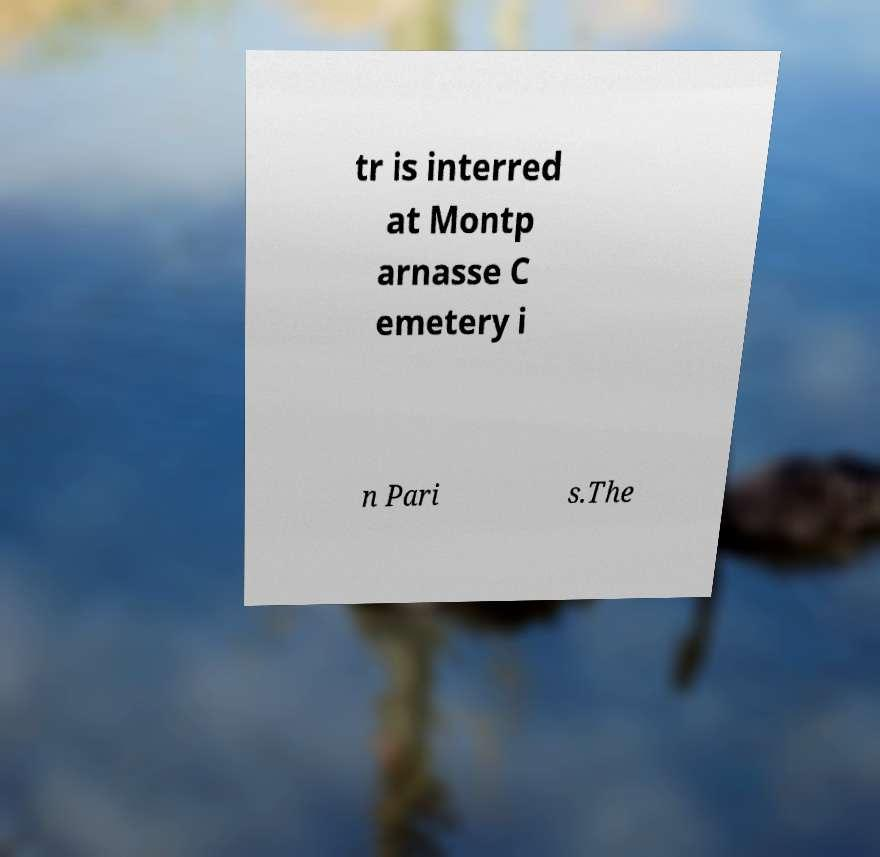Can you read and provide the text displayed in the image?This photo seems to have some interesting text. Can you extract and type it out for me? tr is interred at Montp arnasse C emetery i n Pari s.The 